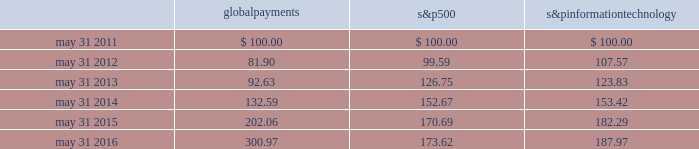Stock performance graph the following graph compares our cumulative shareholder returns with the standard & poor 2019s information technology index and the standard & poor 2019s 500 index for the five years ended may 31 , 2016 .
The line graph assumes the investment of $ 100 in our common stock , the standard & poor 2019s information technology index and the standard & poor 2019s 500 index on may 31 , 2011 and assumes reinvestment of all dividends .
Comparison of 5 year cumulative total return* among global payments inc. , the s&p 500 index and the s&p information technology index 5/11 5/145/135/12 global payments inc .
S&p 500 s&p information technology 5/15 5/16 * $ 100 invested on may 31 , 2011 in stock or index , including reinvestment of dividends .
Fiscal year ending may 31 .
Copyright a9 2016 s&p , a division of the mcgraw-hill companies inc .
All rights reserved .
Global payments information technology .
Issuer purchases of equity securities as announced on july 28 , 2015 , our board of directors authorized the additional repurchase of up to $ 300.0 million of our common stock .
Under these and other existing authorizations , we repurchased and retired 2.2 million shares of our common stock at a cost of $ 135.9 million including commissions , or an average price of $ 63.17 per share , during the year ended may 31 , 2016 .
Global payments inc .
| 2016 form 10-k annual report 2013 29 .
If $ 100000 are invested in s&p500 in may 2011 , what will be the total value of the investment in may 2012? 
Computations: (100000 * (100 - ((99.59 - 100) / 100)))
Answer: 10000410.0. 